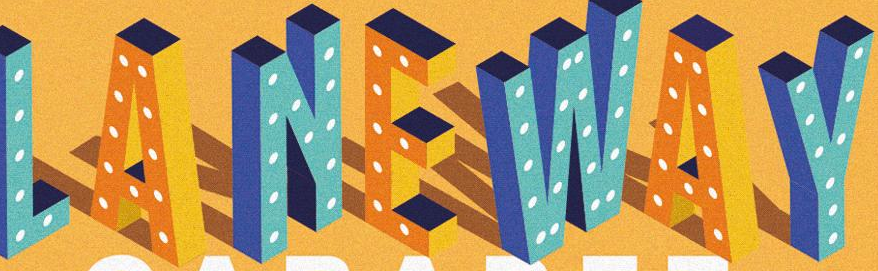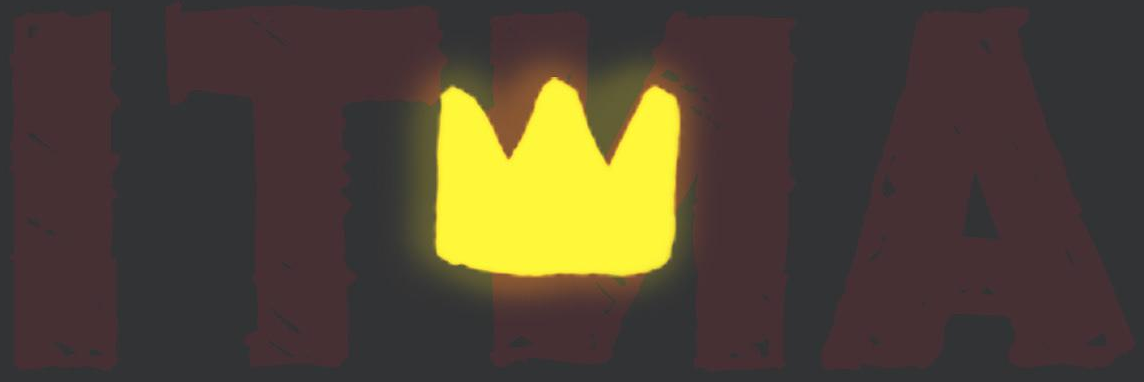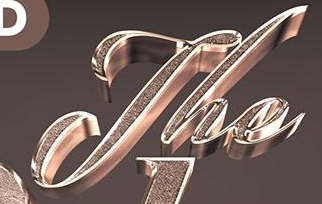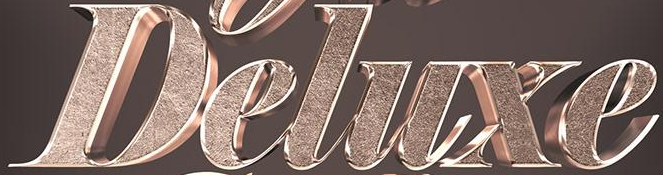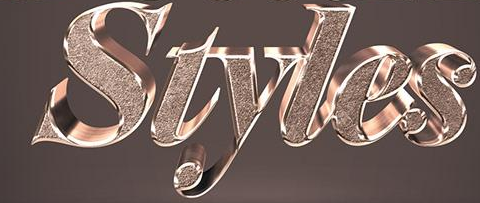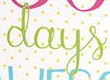What text is displayed in these images sequentially, separated by a semicolon? LANEWAY; ITNA; The; Deluxe; Styles; days 